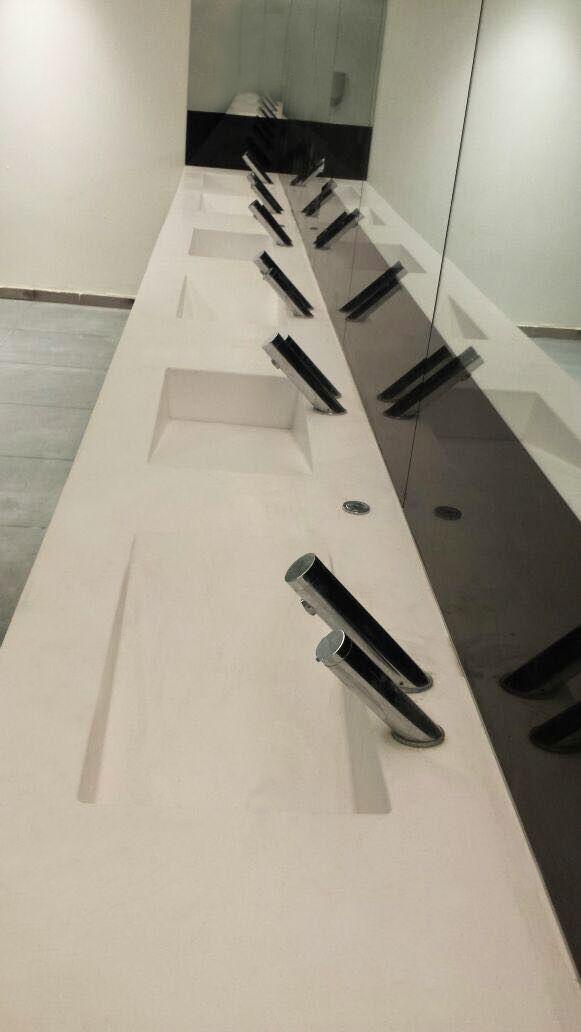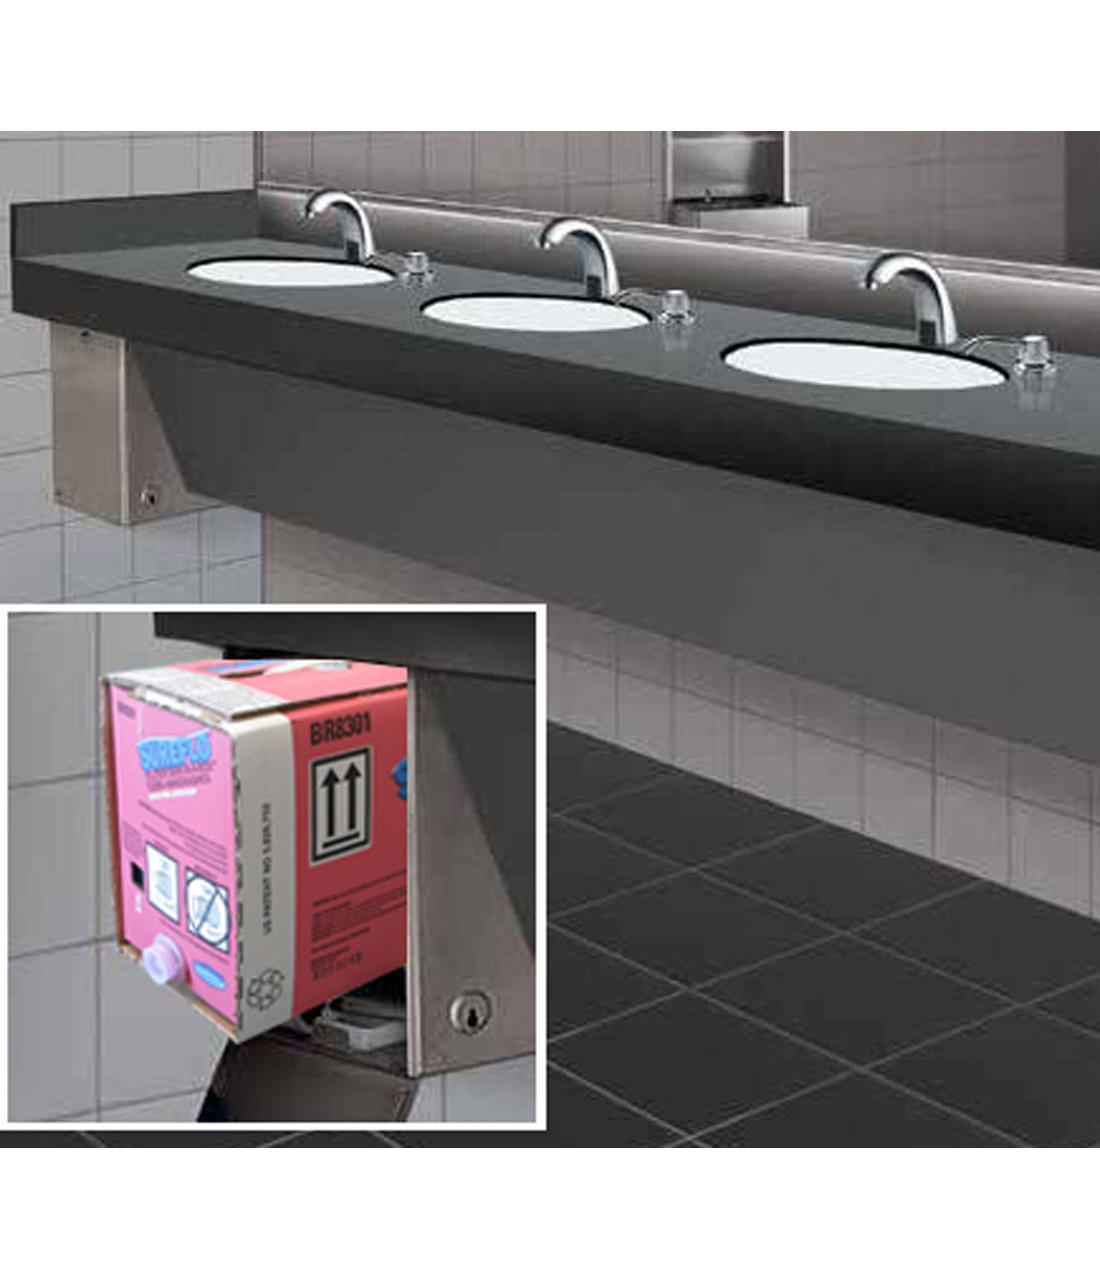The first image is the image on the left, the second image is the image on the right. For the images displayed, is the sentence "More than one cord is visible underneath the faucets and counter-top." factually correct? Answer yes or no. No. 